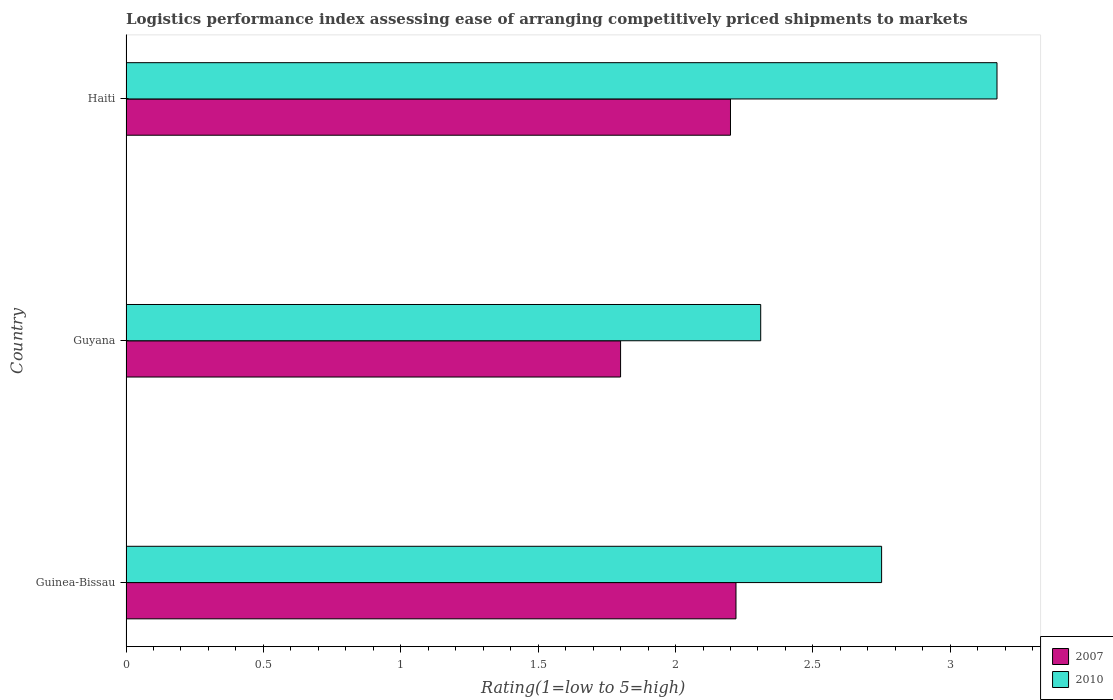How many bars are there on the 1st tick from the top?
Ensure brevity in your answer.  2. How many bars are there on the 3rd tick from the bottom?
Your response must be concise. 2. What is the label of the 3rd group of bars from the top?
Your answer should be very brief. Guinea-Bissau. What is the Logistic performance index in 2010 in Guyana?
Offer a very short reply. 2.31. Across all countries, what is the maximum Logistic performance index in 2010?
Provide a short and direct response. 3.17. Across all countries, what is the minimum Logistic performance index in 2010?
Your answer should be compact. 2.31. In which country was the Logistic performance index in 2007 maximum?
Your response must be concise. Guinea-Bissau. In which country was the Logistic performance index in 2010 minimum?
Keep it short and to the point. Guyana. What is the total Logistic performance index in 2010 in the graph?
Your answer should be very brief. 8.23. What is the difference between the Logistic performance index in 2010 in Guinea-Bissau and that in Guyana?
Your answer should be compact. 0.44. What is the difference between the Logistic performance index in 2010 in Haiti and the Logistic performance index in 2007 in Guinea-Bissau?
Ensure brevity in your answer.  0.95. What is the average Logistic performance index in 2007 per country?
Offer a terse response. 2.07. What is the difference between the Logistic performance index in 2007 and Logistic performance index in 2010 in Guyana?
Your answer should be compact. -0.51. In how many countries, is the Logistic performance index in 2010 greater than 1.3 ?
Provide a short and direct response. 3. What is the ratio of the Logistic performance index in 2007 in Guinea-Bissau to that in Guyana?
Keep it short and to the point. 1.23. What is the difference between the highest and the second highest Logistic performance index in 2010?
Make the answer very short. 0.42. What is the difference between the highest and the lowest Logistic performance index in 2007?
Offer a terse response. 0.42. In how many countries, is the Logistic performance index in 2010 greater than the average Logistic performance index in 2010 taken over all countries?
Give a very brief answer. 2. Is the sum of the Logistic performance index in 2007 in Guyana and Haiti greater than the maximum Logistic performance index in 2010 across all countries?
Offer a very short reply. Yes. How many bars are there?
Your answer should be very brief. 6. Are all the bars in the graph horizontal?
Keep it short and to the point. Yes. How many countries are there in the graph?
Offer a terse response. 3. Are the values on the major ticks of X-axis written in scientific E-notation?
Give a very brief answer. No. Does the graph contain any zero values?
Ensure brevity in your answer.  No. Does the graph contain grids?
Offer a very short reply. No. Where does the legend appear in the graph?
Your answer should be very brief. Bottom right. How many legend labels are there?
Your answer should be very brief. 2. How are the legend labels stacked?
Make the answer very short. Vertical. What is the title of the graph?
Provide a short and direct response. Logistics performance index assessing ease of arranging competitively priced shipments to markets. Does "1982" appear as one of the legend labels in the graph?
Make the answer very short. No. What is the label or title of the X-axis?
Provide a short and direct response. Rating(1=low to 5=high). What is the Rating(1=low to 5=high) of 2007 in Guinea-Bissau?
Your response must be concise. 2.22. What is the Rating(1=low to 5=high) of 2010 in Guinea-Bissau?
Give a very brief answer. 2.75. What is the Rating(1=low to 5=high) of 2007 in Guyana?
Your answer should be very brief. 1.8. What is the Rating(1=low to 5=high) in 2010 in Guyana?
Provide a succinct answer. 2.31. What is the Rating(1=low to 5=high) of 2010 in Haiti?
Provide a short and direct response. 3.17. Across all countries, what is the maximum Rating(1=low to 5=high) in 2007?
Provide a short and direct response. 2.22. Across all countries, what is the maximum Rating(1=low to 5=high) of 2010?
Give a very brief answer. 3.17. Across all countries, what is the minimum Rating(1=low to 5=high) in 2010?
Provide a succinct answer. 2.31. What is the total Rating(1=low to 5=high) of 2007 in the graph?
Ensure brevity in your answer.  6.22. What is the total Rating(1=low to 5=high) of 2010 in the graph?
Make the answer very short. 8.23. What is the difference between the Rating(1=low to 5=high) of 2007 in Guinea-Bissau and that in Guyana?
Offer a terse response. 0.42. What is the difference between the Rating(1=low to 5=high) in 2010 in Guinea-Bissau and that in Guyana?
Provide a succinct answer. 0.44. What is the difference between the Rating(1=low to 5=high) in 2010 in Guinea-Bissau and that in Haiti?
Offer a terse response. -0.42. What is the difference between the Rating(1=low to 5=high) in 2010 in Guyana and that in Haiti?
Keep it short and to the point. -0.86. What is the difference between the Rating(1=low to 5=high) in 2007 in Guinea-Bissau and the Rating(1=low to 5=high) in 2010 in Guyana?
Keep it short and to the point. -0.09. What is the difference between the Rating(1=low to 5=high) in 2007 in Guinea-Bissau and the Rating(1=low to 5=high) in 2010 in Haiti?
Your answer should be very brief. -0.95. What is the difference between the Rating(1=low to 5=high) of 2007 in Guyana and the Rating(1=low to 5=high) of 2010 in Haiti?
Your response must be concise. -1.37. What is the average Rating(1=low to 5=high) of 2007 per country?
Provide a succinct answer. 2.07. What is the average Rating(1=low to 5=high) of 2010 per country?
Your answer should be compact. 2.74. What is the difference between the Rating(1=low to 5=high) of 2007 and Rating(1=low to 5=high) of 2010 in Guinea-Bissau?
Give a very brief answer. -0.53. What is the difference between the Rating(1=low to 5=high) in 2007 and Rating(1=low to 5=high) in 2010 in Guyana?
Keep it short and to the point. -0.51. What is the difference between the Rating(1=low to 5=high) in 2007 and Rating(1=low to 5=high) in 2010 in Haiti?
Your response must be concise. -0.97. What is the ratio of the Rating(1=low to 5=high) in 2007 in Guinea-Bissau to that in Guyana?
Ensure brevity in your answer.  1.23. What is the ratio of the Rating(1=low to 5=high) of 2010 in Guinea-Bissau to that in Guyana?
Offer a terse response. 1.19. What is the ratio of the Rating(1=low to 5=high) in 2007 in Guinea-Bissau to that in Haiti?
Provide a short and direct response. 1.01. What is the ratio of the Rating(1=low to 5=high) of 2010 in Guinea-Bissau to that in Haiti?
Provide a succinct answer. 0.87. What is the ratio of the Rating(1=low to 5=high) of 2007 in Guyana to that in Haiti?
Ensure brevity in your answer.  0.82. What is the ratio of the Rating(1=low to 5=high) of 2010 in Guyana to that in Haiti?
Keep it short and to the point. 0.73. What is the difference between the highest and the second highest Rating(1=low to 5=high) of 2010?
Your answer should be very brief. 0.42. What is the difference between the highest and the lowest Rating(1=low to 5=high) in 2007?
Your answer should be very brief. 0.42. What is the difference between the highest and the lowest Rating(1=low to 5=high) in 2010?
Offer a very short reply. 0.86. 